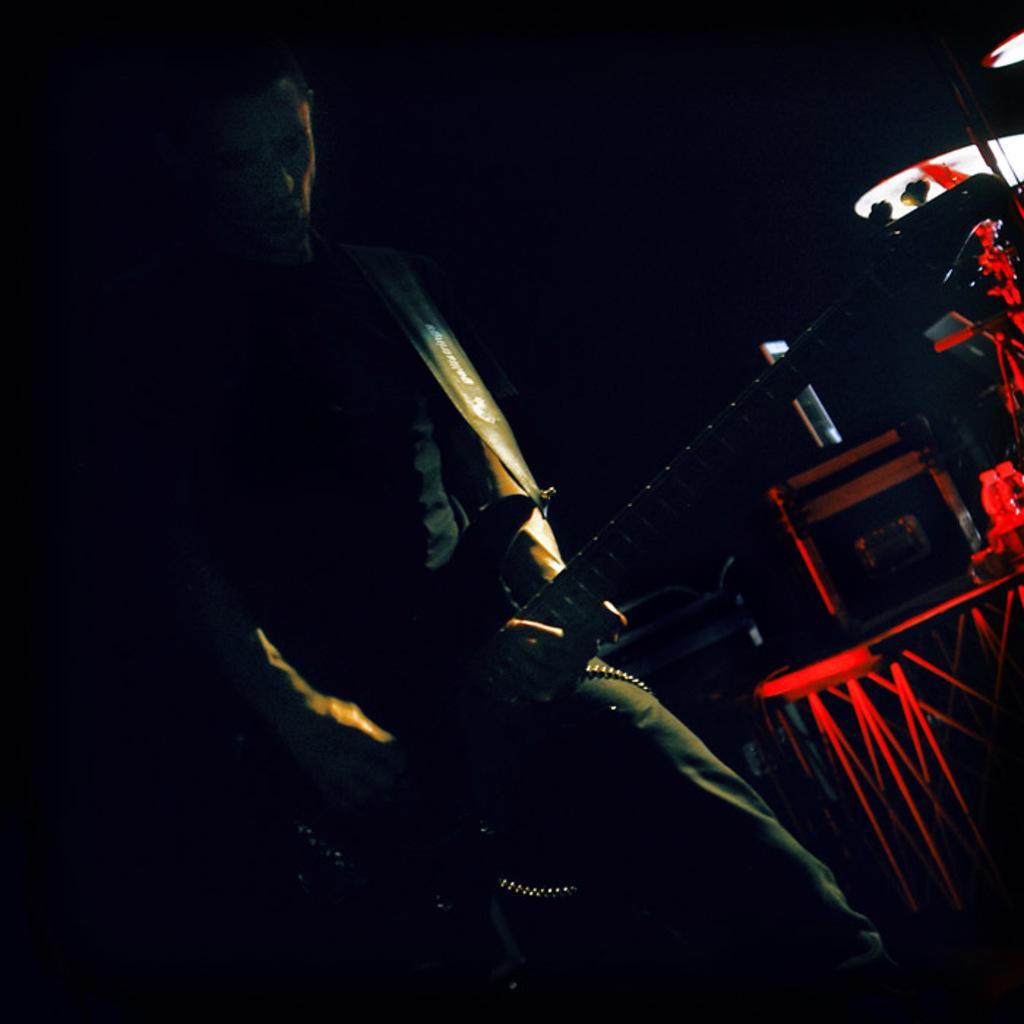Can you describe this image briefly? In the center of the image we can see a man standing and holding a guitar. On the right there is a band and a speaker. 